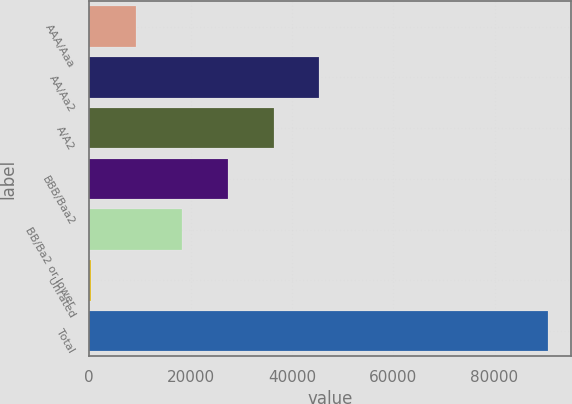Convert chart. <chart><loc_0><loc_0><loc_500><loc_500><bar_chart><fcel>AAA/Aaa<fcel>AA/Aa2<fcel>A/A2<fcel>BBB/Baa2<fcel>BB/Ba2 or lower<fcel>Unrated<fcel>Total<nl><fcel>9274.1<fcel>45418.5<fcel>36382.4<fcel>27346.3<fcel>18310.2<fcel>238<fcel>90599<nl></chart> 